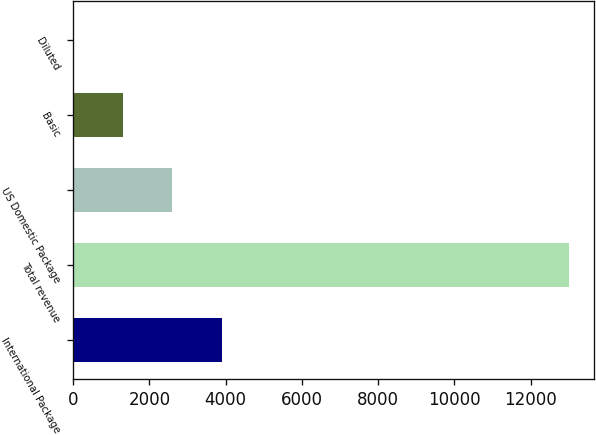Convert chart. <chart><loc_0><loc_0><loc_500><loc_500><bar_chart><fcel>International Package<fcel>Total revenue<fcel>US Domestic Package<fcel>Basic<fcel>Diluted<nl><fcel>3900.9<fcel>13001<fcel>2600.89<fcel>1300.87<fcel>0.85<nl></chart> 